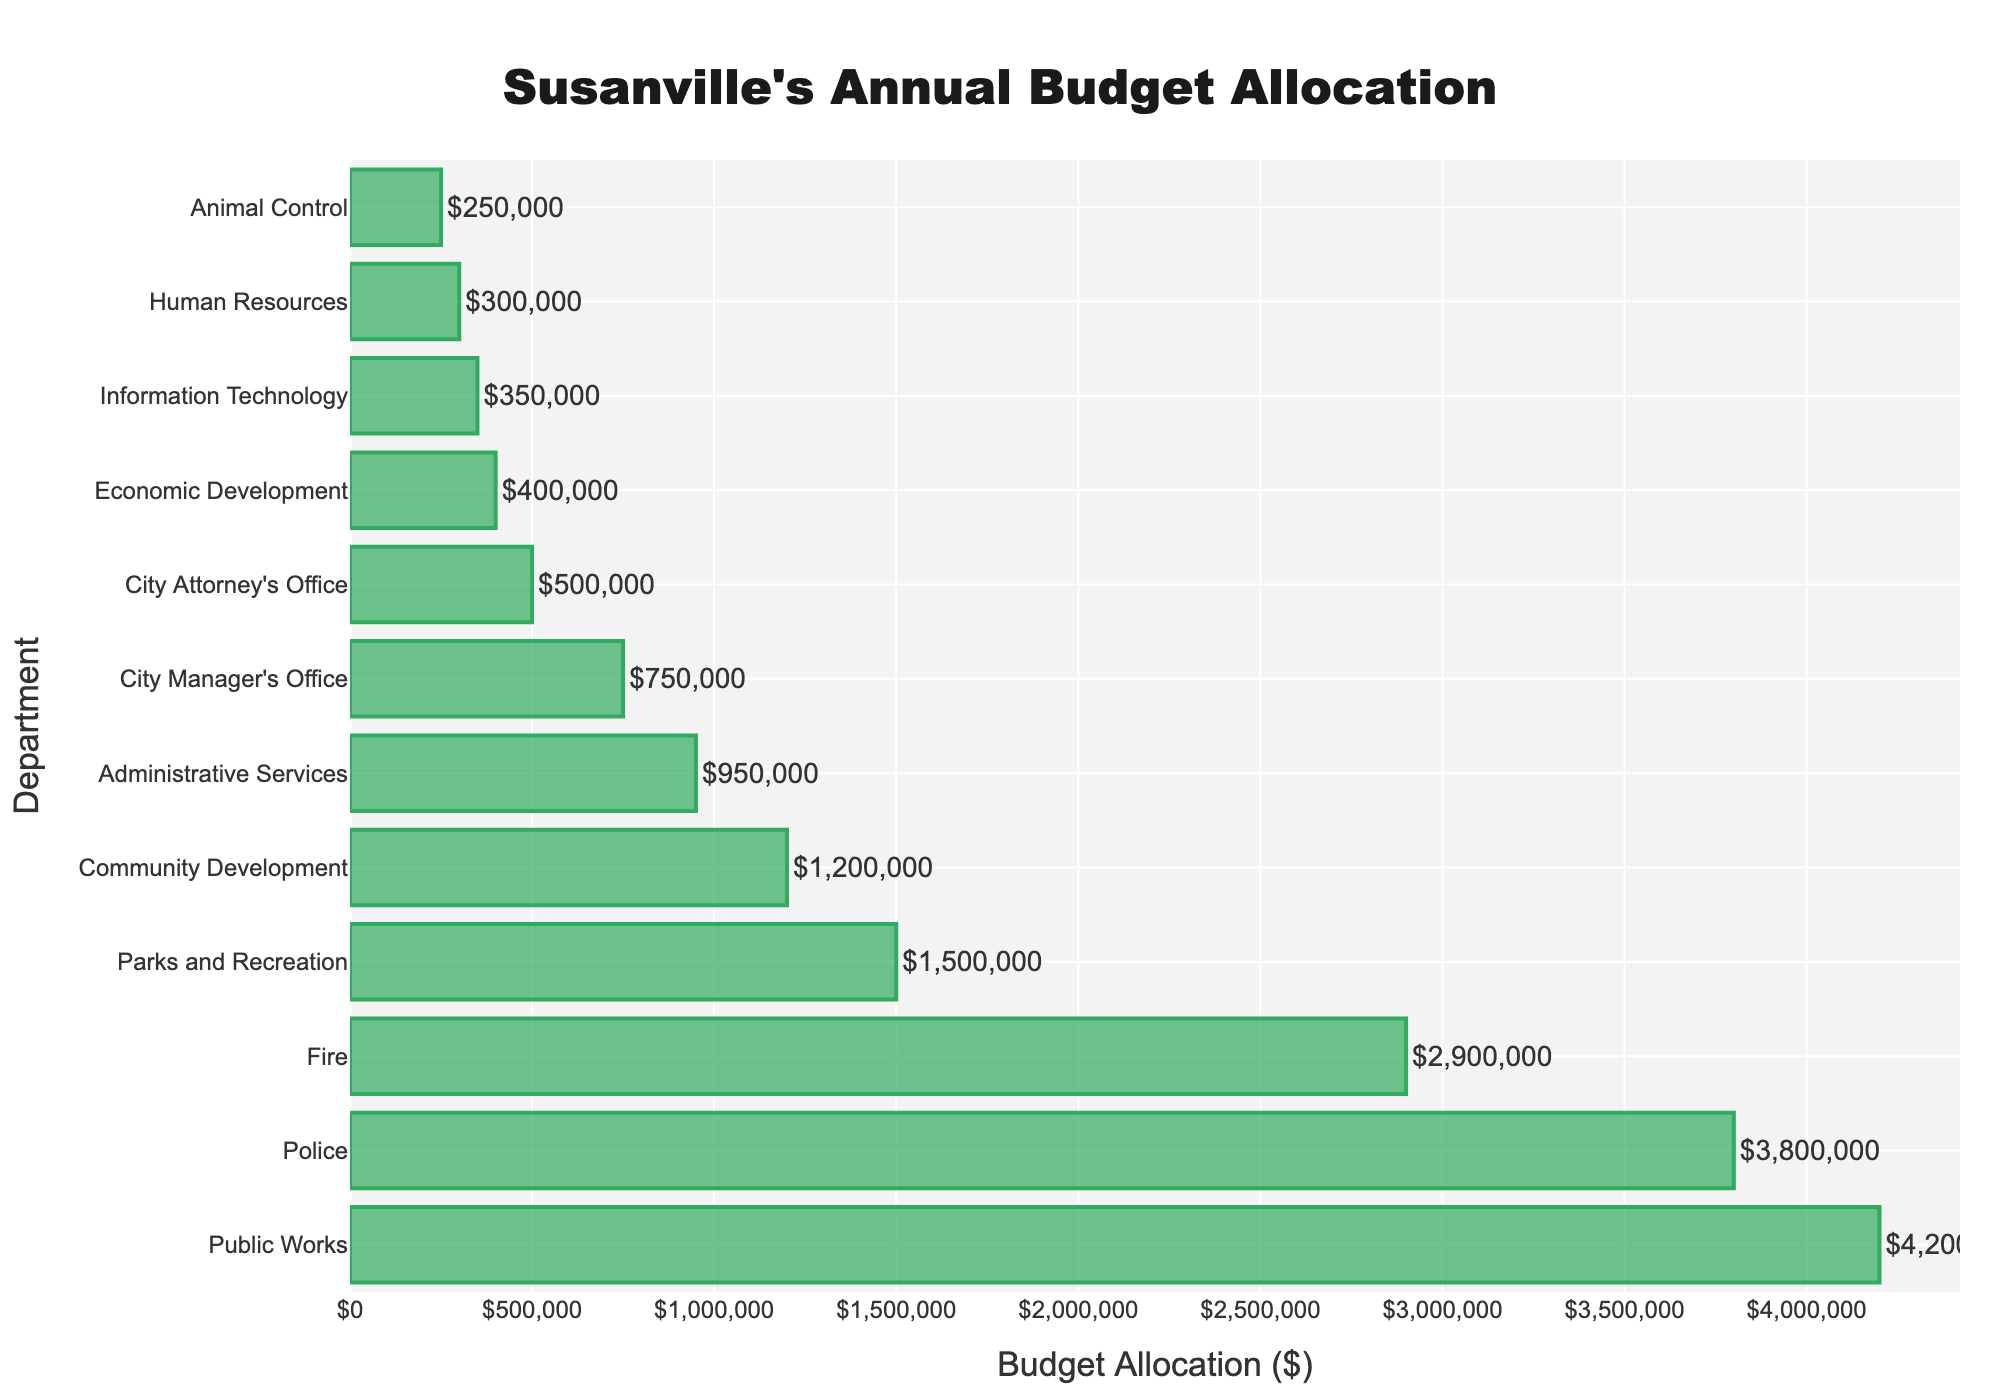What's the total budget allocation for Public Works and Police departments combined? First, find the budget for Public Works ($4,200,000) and Police ($3,800,000). Then, sum them up: $4,200,000 + $3,800,000 = $8,000,000
Answer: $8,000,000 Which department has the lowest budget allocation? Refer to the y-axis to identify the department with the shortest bar. The shortest bar correlates with the Animal Control department, which has the lowest budget allocation of $250,000
Answer: Animal Control How much more is allocated to Public Works than to Fire? Find the budget for Public Works ($4,200,000) and Fire ($2,900,000). Subtract Fire's budget from Public Works' budget: $4,200,000 - $2,900,000 = $1,300,000
Answer: $1,300,000 Which departments have a budget allocation greater than $1,000,000? Identify the departments whose bars extend beyond the $1,000,000 mark on the x-axis: Public Works, Police, Fire, Parks and Recreation, Community Development
Answer: Public Works, Police, Fire, Parks and Recreation, Community Development What is the average budget allocation for all departments? Sum all budget allocations: ($4,200,000 + $3,800,000 + $2,900,000 + $1,500,000 + $1,200,000 + $950,000 + $750,000 + $500,000 + $400,000 + $350,000 + $300,000 + $250,000) = $17,100,000. Divide by the number of departments (12): $17,100,000 / 12 ≈ $1,425,000
Answer: $1,425,000 Is the budget allocation for Parks and Recreation higher or lower than for Administrative Services? By how much? Parks and Recreation has a budget of $1,500,000, while Administrative Services has $950,000. Calculate the difference: $1,500,000 - $950,000 = $550,000. Parks and Recreation has a higher budget by $550,000
Answer: Higher by $550,000 What's the difference in budget allocation between the City Manager's Office and the City Attorney's Office? Identify the budgets: City Manager's Office ($750,000) and City Attorney's Office ($500,000). Subtract to find the difference: $750,000 - $500,000 = $250,000
Answer: $250,000 What proportion of the total budget is allocated to Economic Development? The total budget is $17,100,000. Economic Development's allocation is $400,000. Divide and convert to percentage: ($400,000 / $17,100,000) × 100 ≈ 2.34%
Answer: 2.34% Compare the budget allocations for Information Technology and Human Resources. Which one is higher and by how much? Find the budgets: Information Technology ($350,000) and Human Resources ($300,000). Information Technology has a higher budget, with a difference of $350,000 - $300,000 = $50,000
Answer: Information Technology by $50,000 